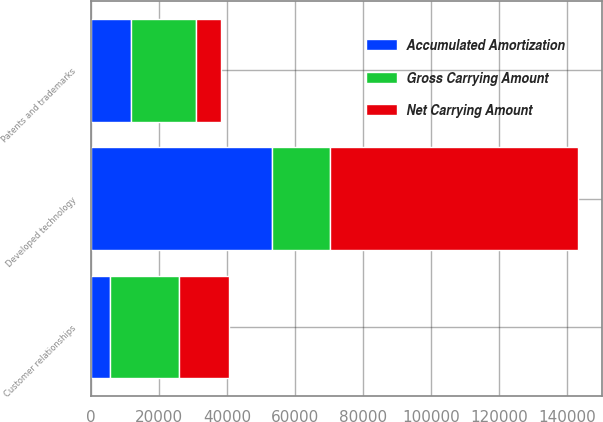Convert chart. <chart><loc_0><loc_0><loc_500><loc_500><stacked_bar_chart><ecel><fcel>Developed technology<fcel>Customer relationships<fcel>Patents and trademarks<nl><fcel>Gross Carrying Amount<fcel>16934.5<fcel>20242<fcel>19160<nl><fcel>Accumulated Amortization<fcel>53213<fcel>5533<fcel>11800<nl><fcel>Net Carrying Amount<fcel>72960<fcel>14709<fcel>7360<nl></chart> 